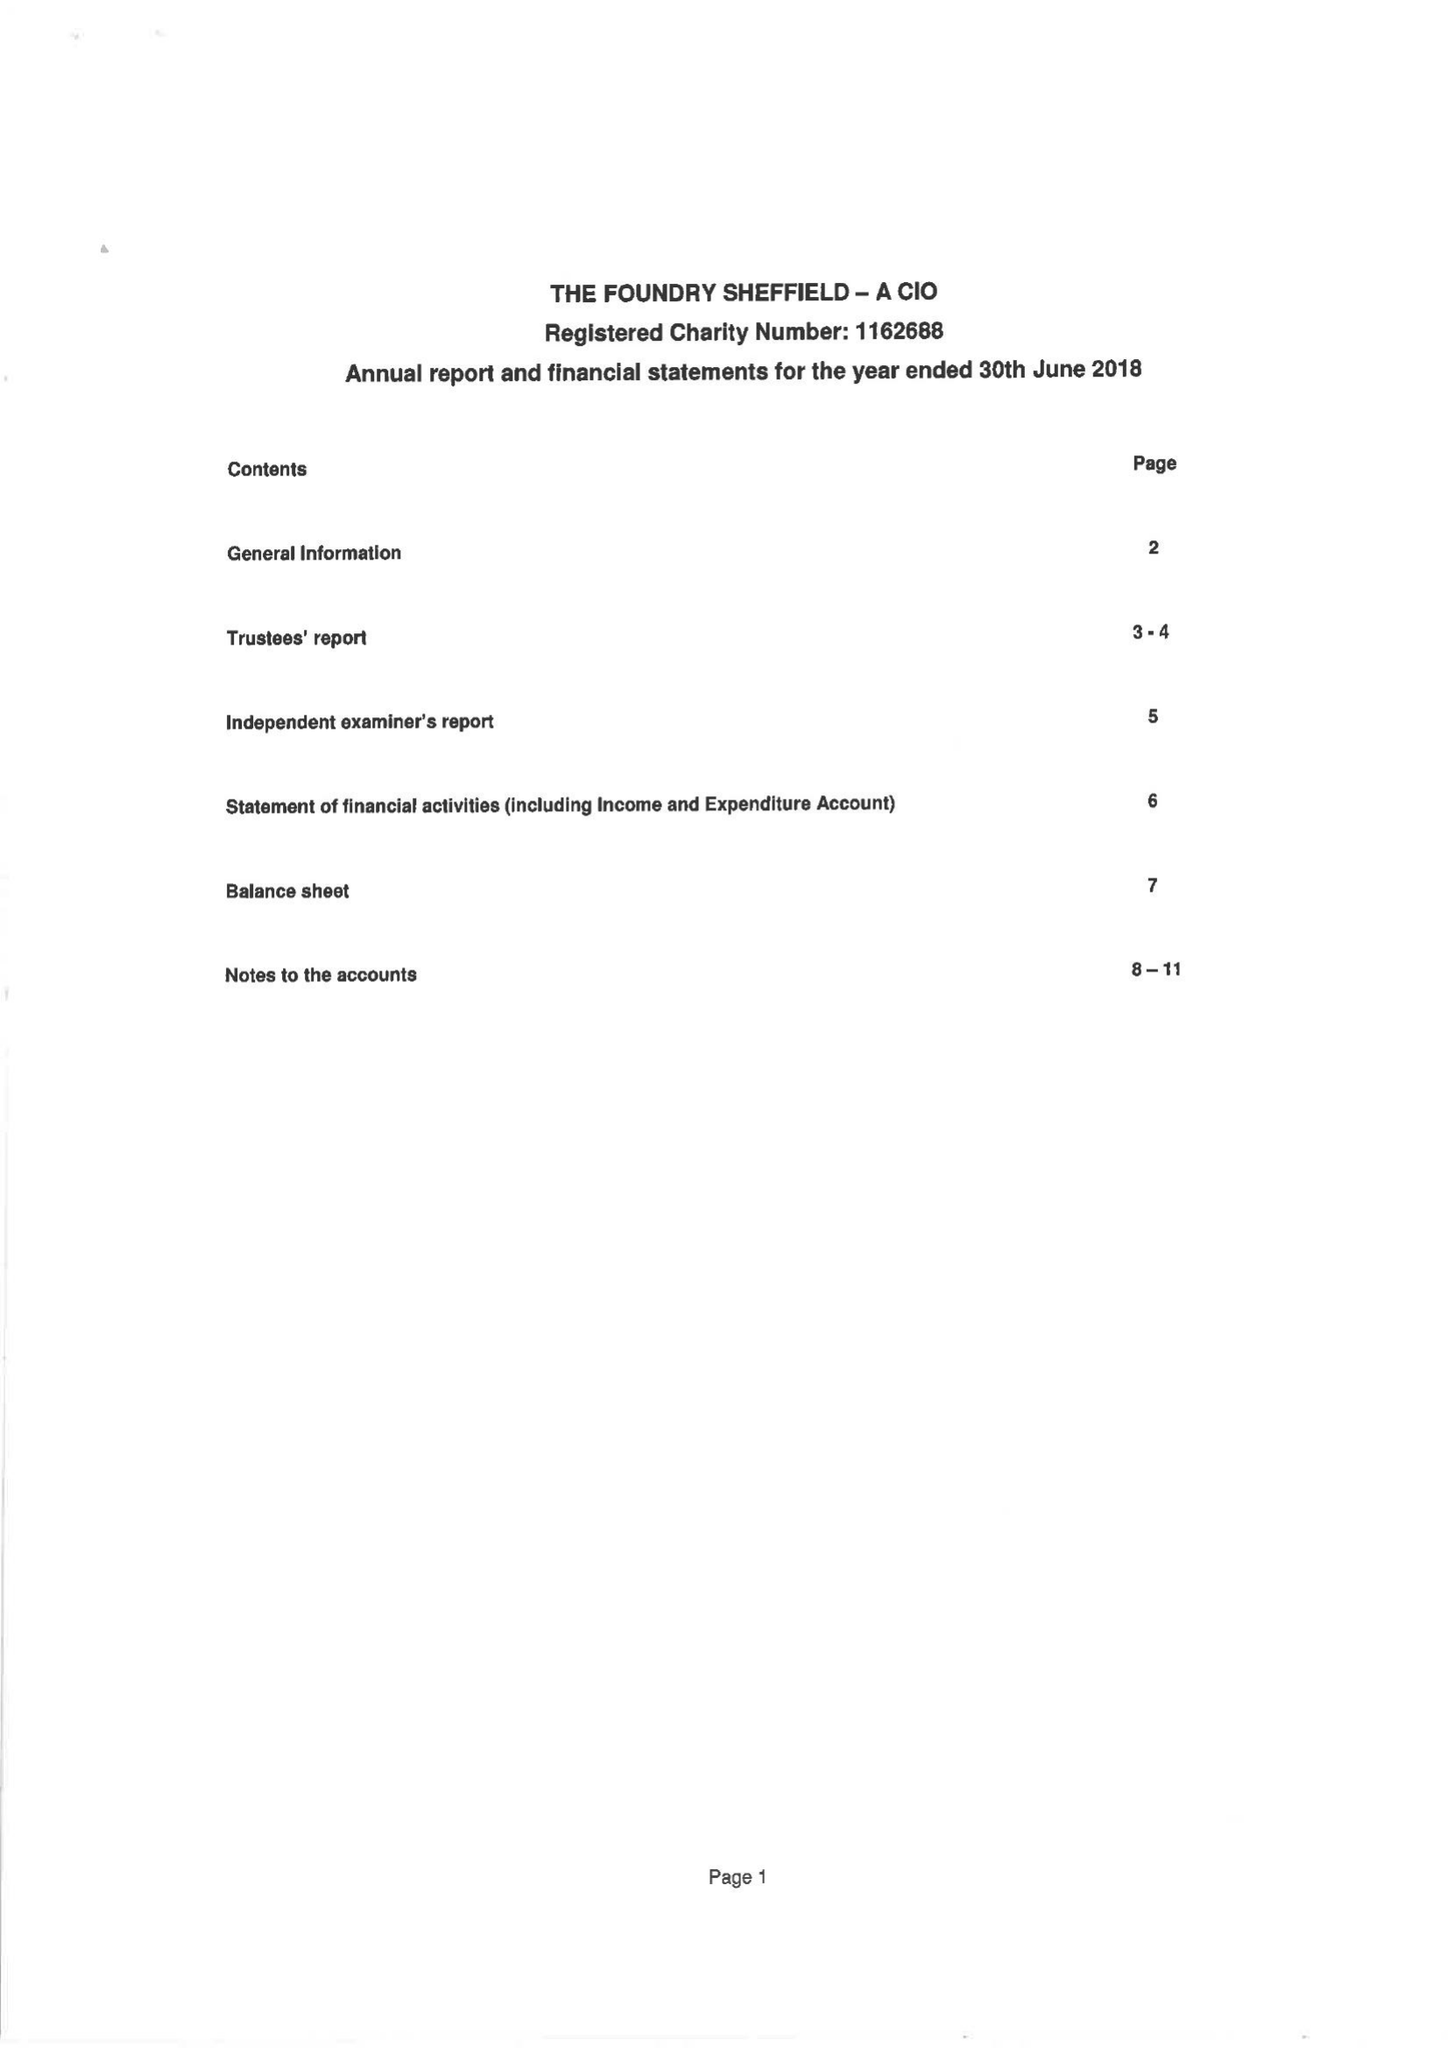What is the value for the charity_name?
Answer the question using a single word or phrase. The Foundry Sheffield 